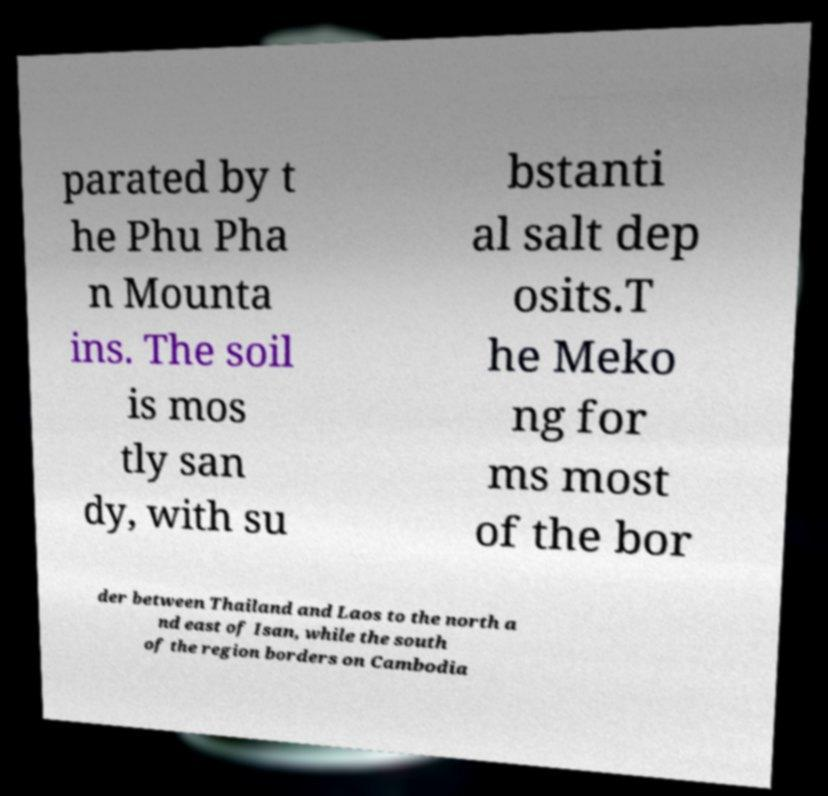What messages or text are displayed in this image? I need them in a readable, typed format. parated by t he Phu Pha n Mounta ins. The soil is mos tly san dy, with su bstanti al salt dep osits.T he Meko ng for ms most of the bor der between Thailand and Laos to the north a nd east of Isan, while the south of the region borders on Cambodia 